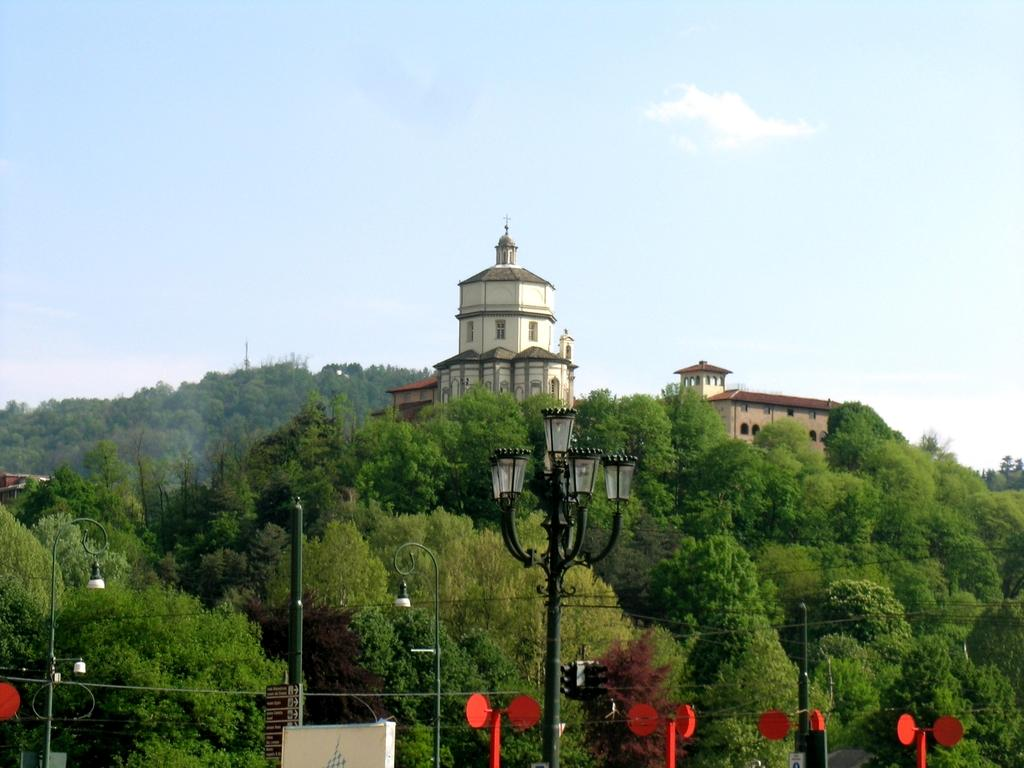What type of objects are attached to the poles in the image? There are lights attached to the poles in the image. What color can be seen among the items in the image? There are red items in the image. What can be seen in the distance behind the poles and lights? There are trees, buildings, and the sky visible in the background of the image. Are there any fairies visible in the image? There are no fairies present in the image. What type of fuel is being used by the lights on the poles? The image does not provide information about the type of fuel used by the lights on the poles. 